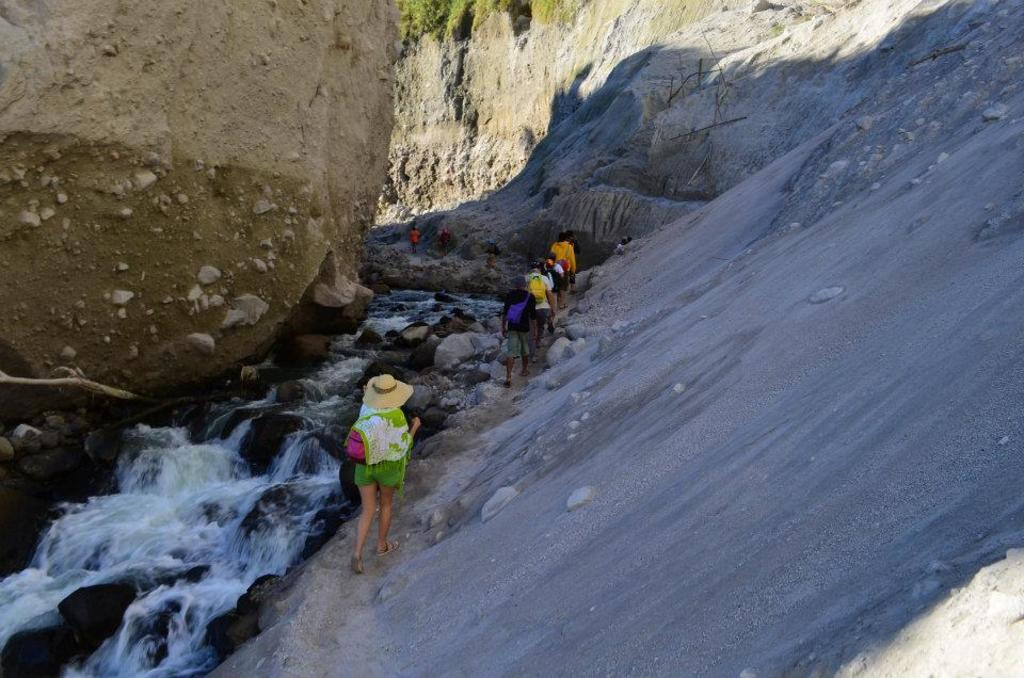What can be seen in the image involving people? There are people standing in the image. What is located on the left side of the image? There is water visible on the left side of the image. What type of natural feature is present in the image? Rocks are present in the image. What large geological formation can be seen in the image? There is a mountain in the image. What type of fruit is being shared by the people in the image? There is no fruit present in the image; the people are not sharing any fruit. 